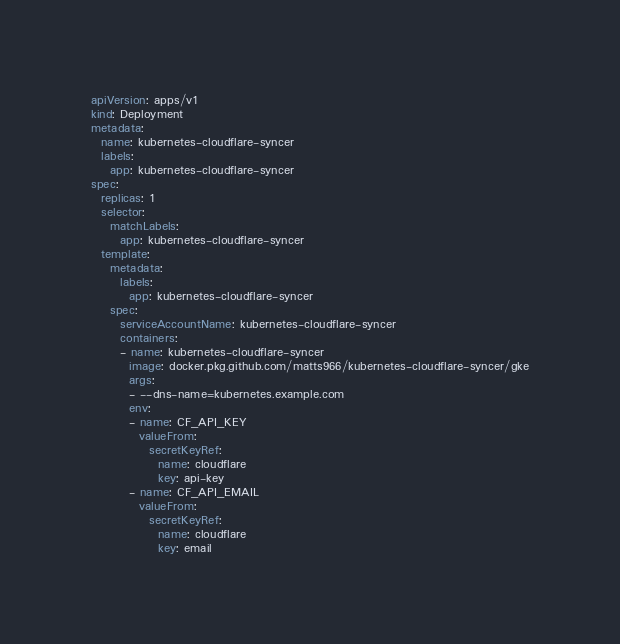Convert code to text. <code><loc_0><loc_0><loc_500><loc_500><_YAML_>apiVersion: apps/v1
kind: Deployment
metadata:
  name: kubernetes-cloudflare-syncer
  labels:
    app: kubernetes-cloudflare-syncer
spec:
  replicas: 1
  selector:
    matchLabels:
      app: kubernetes-cloudflare-syncer
  template:
    metadata:
      labels:
        app: kubernetes-cloudflare-syncer
    spec:
      serviceAccountName: kubernetes-cloudflare-syncer
      containers:
      - name: kubernetes-cloudflare-syncer
        image: docker.pkg.github.com/matts966/kubernetes-cloudflare-syncer/gke
        args:
        - --dns-name=kubernetes.example.com
        env:
        - name: CF_API_KEY
          valueFrom:
            secretKeyRef:
              name: cloudflare
              key: api-key
        - name: CF_API_EMAIL
          valueFrom:
            secretKeyRef:
              name: cloudflare
              key: email
</code> 